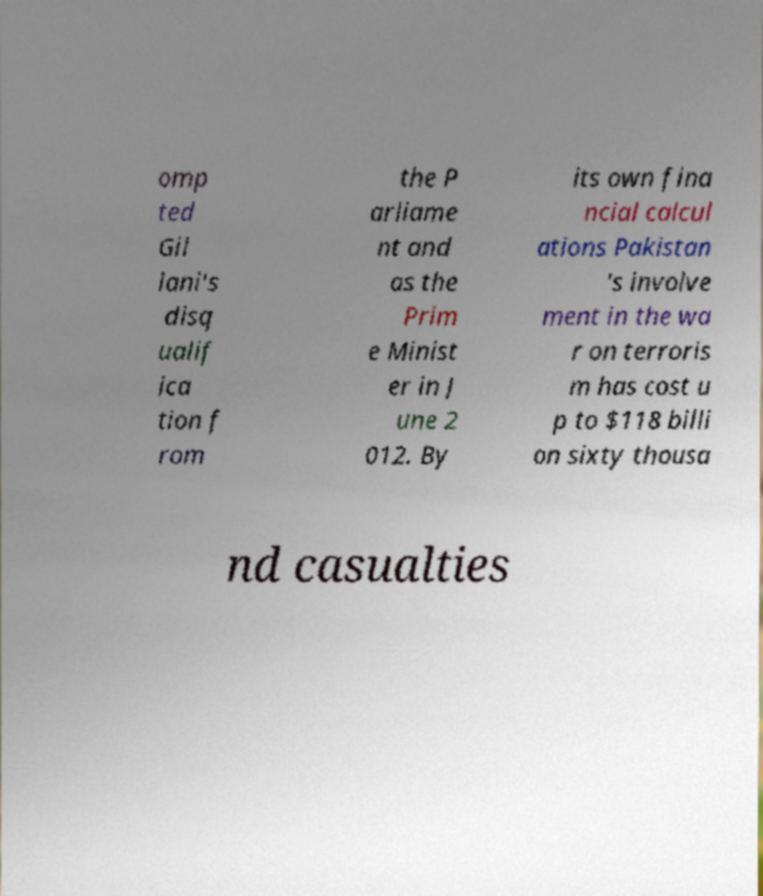Could you extract and type out the text from this image? omp ted Gil lani's disq ualif ica tion f rom the P arliame nt and as the Prim e Minist er in J une 2 012. By its own fina ncial calcul ations Pakistan 's involve ment in the wa r on terroris m has cost u p to $118 billi on sixty thousa nd casualties 